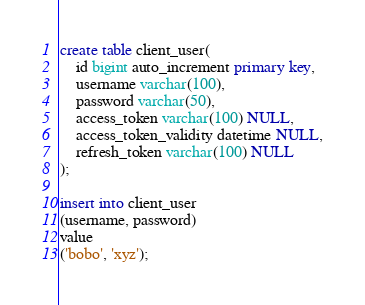<code> <loc_0><loc_0><loc_500><loc_500><_SQL_>create table client_user(
    id bigint auto_increment primary key,
    username varchar(100),
    password varchar(50),
    access_token varchar(100) NULL,
    access_token_validity datetime NULL,
    refresh_token varchar(100) NULL
);

insert into client_user
(username, password)
value
('bobo', 'xyz');
</code> 